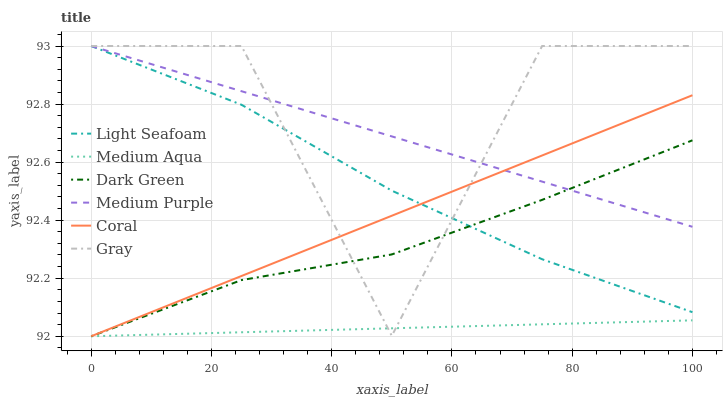Does Medium Aqua have the minimum area under the curve?
Answer yes or no. Yes. Does Gray have the maximum area under the curve?
Answer yes or no. Yes. Does Coral have the minimum area under the curve?
Answer yes or no. No. Does Coral have the maximum area under the curve?
Answer yes or no. No. Is Medium Aqua the smoothest?
Answer yes or no. Yes. Is Gray the roughest?
Answer yes or no. Yes. Is Coral the smoothest?
Answer yes or no. No. Is Coral the roughest?
Answer yes or no. No. Does Coral have the lowest value?
Answer yes or no. Yes. Does Medium Purple have the lowest value?
Answer yes or no. No. Does Light Seafoam have the highest value?
Answer yes or no. Yes. Does Coral have the highest value?
Answer yes or no. No. Is Medium Aqua less than Light Seafoam?
Answer yes or no. Yes. Is Light Seafoam greater than Medium Aqua?
Answer yes or no. Yes. Does Dark Green intersect Medium Purple?
Answer yes or no. Yes. Is Dark Green less than Medium Purple?
Answer yes or no. No. Is Dark Green greater than Medium Purple?
Answer yes or no. No. Does Medium Aqua intersect Light Seafoam?
Answer yes or no. No. 